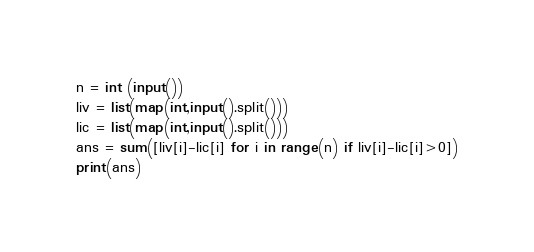Convert code to text. <code><loc_0><loc_0><loc_500><loc_500><_Python_>n = int (input())
liv = list(map(int,input().split()))
lic = list(map(int,input().split()))
ans = sum([liv[i]-lic[i] for i in range(n) if liv[i]-lic[i]>0])
print(ans)</code> 